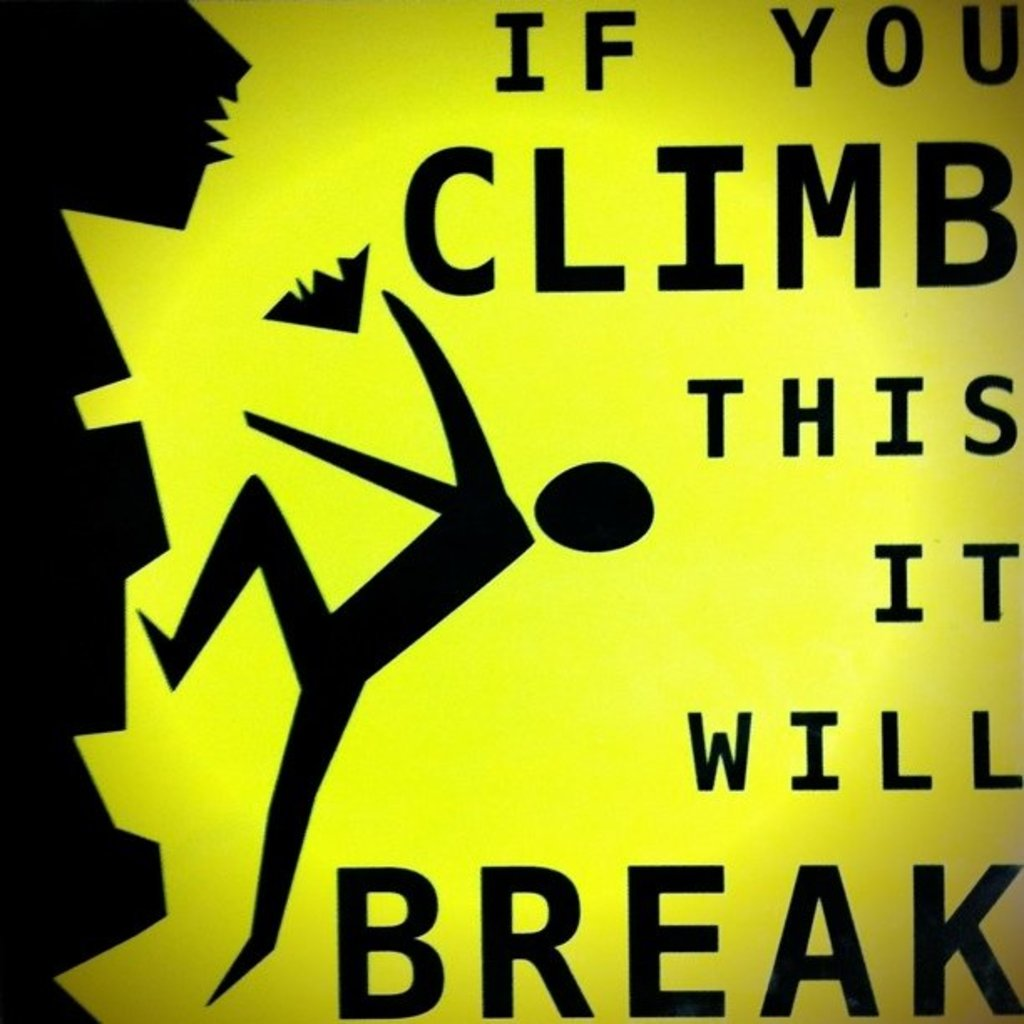Explain the visual content of the image in great detail. The image displays a vivid yellow warning sign featuring a graphic representation in black. The sign depicts a humanoid figure in the act of climbing, with an arm extended and one leg raised, suggesting motion. The figure’s other leg appears to be breaking a part of the structure it is climbing on, highlighted by jagged lines representing cracks, which underscores the fragility of the structure. Text on the sign provides a clear warning: 'If you climb this it will break.' This stark messaging and the choice of a bright, attention-grabbing color, aims to prevent potential injuries by clearly stating that the structure cannot support a person's weight. This type of sign is particularly important in public or unsafe areas where people might be tempted to climb structures that are not designed to hold human weight. 